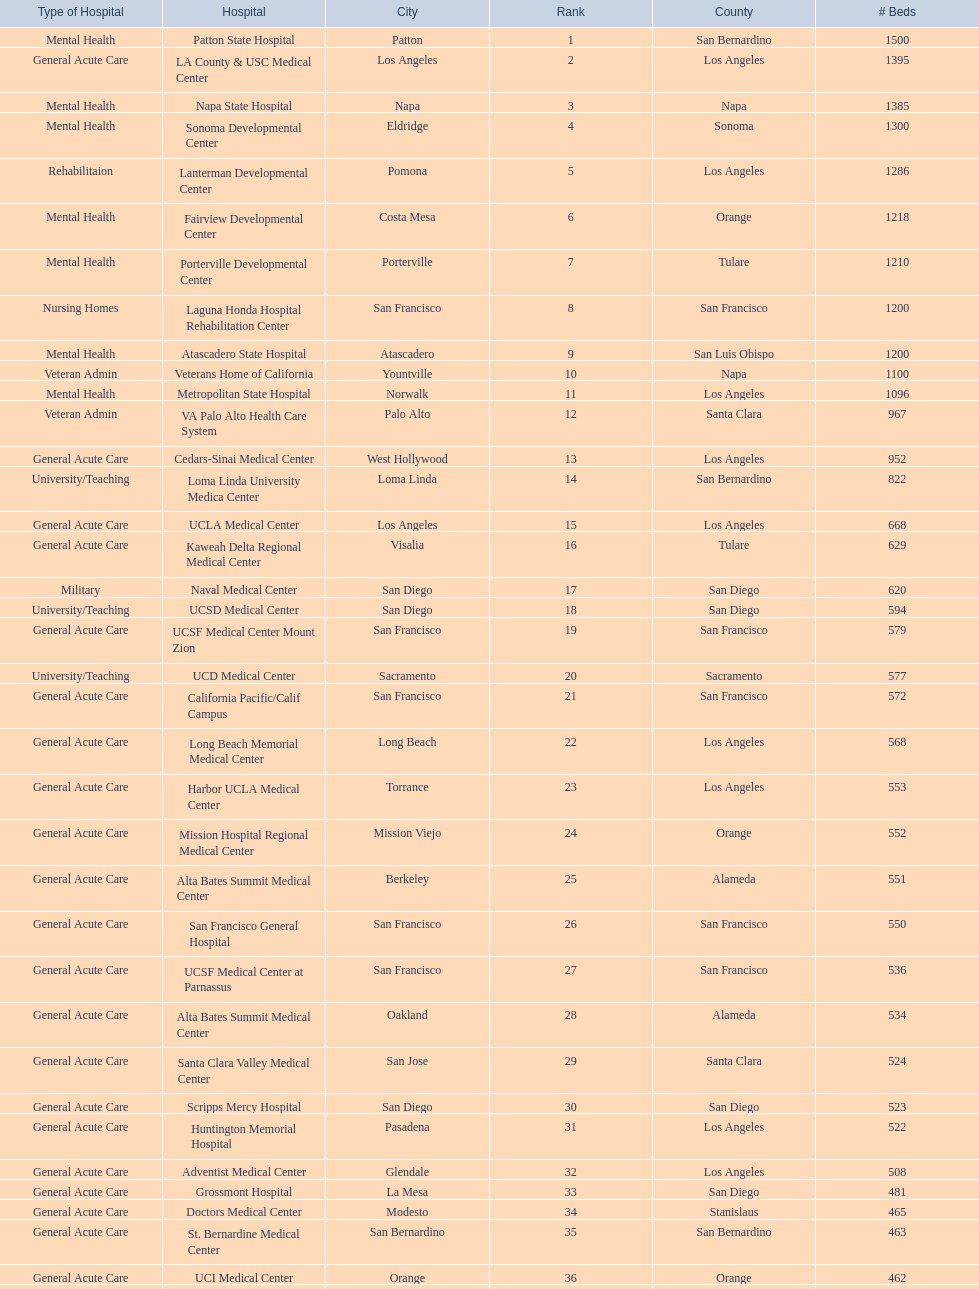Does patton state hospital in the city of patton in san bernardino county have more mental health hospital beds than atascadero state hospital in atascadero, san luis obispo county? Yes. 